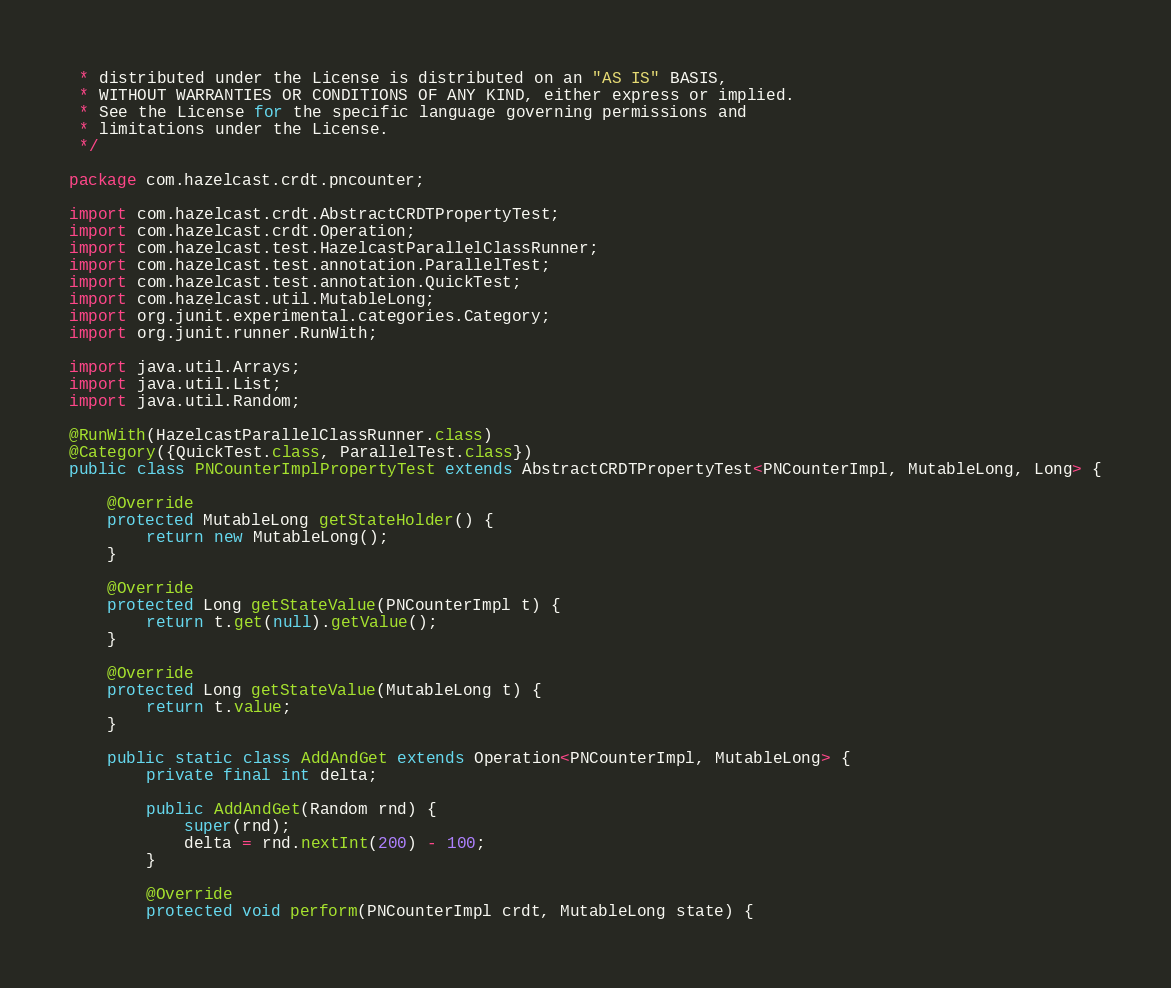<code> <loc_0><loc_0><loc_500><loc_500><_Java_> * distributed under the License is distributed on an "AS IS" BASIS,
 * WITHOUT WARRANTIES OR CONDITIONS OF ANY KIND, either express or implied.
 * See the License for the specific language governing permissions and
 * limitations under the License.
 */

package com.hazelcast.crdt.pncounter;

import com.hazelcast.crdt.AbstractCRDTPropertyTest;
import com.hazelcast.crdt.Operation;
import com.hazelcast.test.HazelcastParallelClassRunner;
import com.hazelcast.test.annotation.ParallelTest;
import com.hazelcast.test.annotation.QuickTest;
import com.hazelcast.util.MutableLong;
import org.junit.experimental.categories.Category;
import org.junit.runner.RunWith;

import java.util.Arrays;
import java.util.List;
import java.util.Random;

@RunWith(HazelcastParallelClassRunner.class)
@Category({QuickTest.class, ParallelTest.class})
public class PNCounterImplPropertyTest extends AbstractCRDTPropertyTest<PNCounterImpl, MutableLong, Long> {

    @Override
    protected MutableLong getStateHolder() {
        return new MutableLong();
    }

    @Override
    protected Long getStateValue(PNCounterImpl t) {
        return t.get(null).getValue();
    }

    @Override
    protected Long getStateValue(MutableLong t) {
        return t.value;
    }

    public static class AddAndGet extends Operation<PNCounterImpl, MutableLong> {
        private final int delta;

        public AddAndGet(Random rnd) {
            super(rnd);
            delta = rnd.nextInt(200) - 100;
        }

        @Override
        protected void perform(PNCounterImpl crdt, MutableLong state) {</code> 